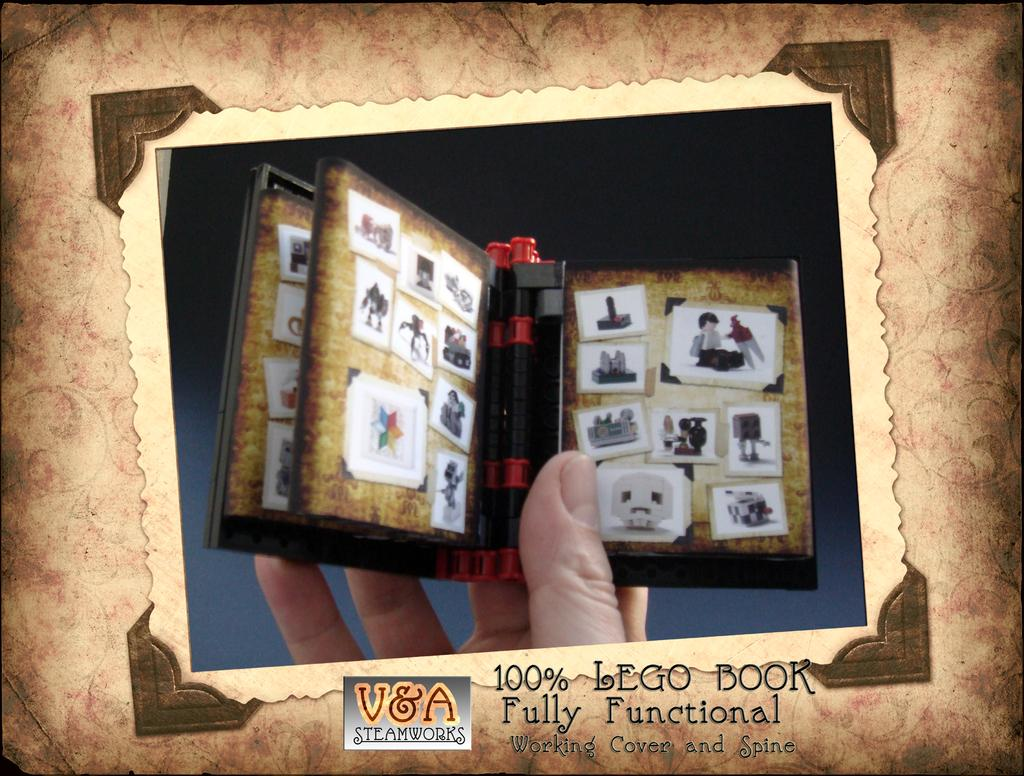What is visible in the foreground of the image? There is a person's hand in the foreground of the image. What is the hand holding? The hand is holding a notepad-like object. Where is the zoo located in the image? There is no zoo present in the image. How many legs does the person have in the image? The image only shows a person's hand, so it is not possible to determine the number of legs. 